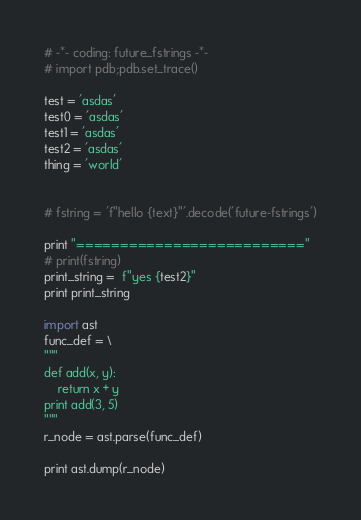<code> <loc_0><loc_0><loc_500><loc_500><_Python_># -*- coding: future_fstrings -*-
# import pdb;pdb.set_trace()

test = 'asdas'
test0 = 'asdas'
test1 = 'asdas'
test2 = 'asdas'
thing = 'world'


# fstring = 'f"hello {text}"'.decode('future-fstrings')

print "=========================="
# print(fstring)
print_string =  f"yes {test2}"
print print_string

import ast
func_def = \
"""
def add(x, y):
    return x + y
print add(3, 5)
"""
r_node = ast.parse(func_def)

print ast.dump(r_node)</code> 